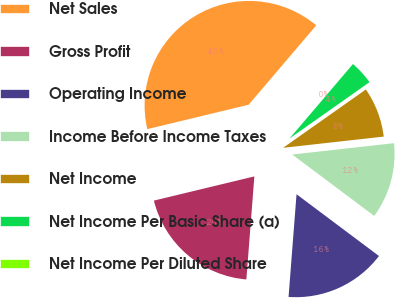<chart> <loc_0><loc_0><loc_500><loc_500><pie_chart><fcel>Net Sales<fcel>Gross Profit<fcel>Operating Income<fcel>Income Before Income Taxes<fcel>Net Income<fcel>Net Income Per Basic Share (a)<fcel>Net Income Per Diluted Share<nl><fcel>39.99%<fcel>20.0%<fcel>16.0%<fcel>12.0%<fcel>8.0%<fcel>4.0%<fcel>0.0%<nl></chart> 